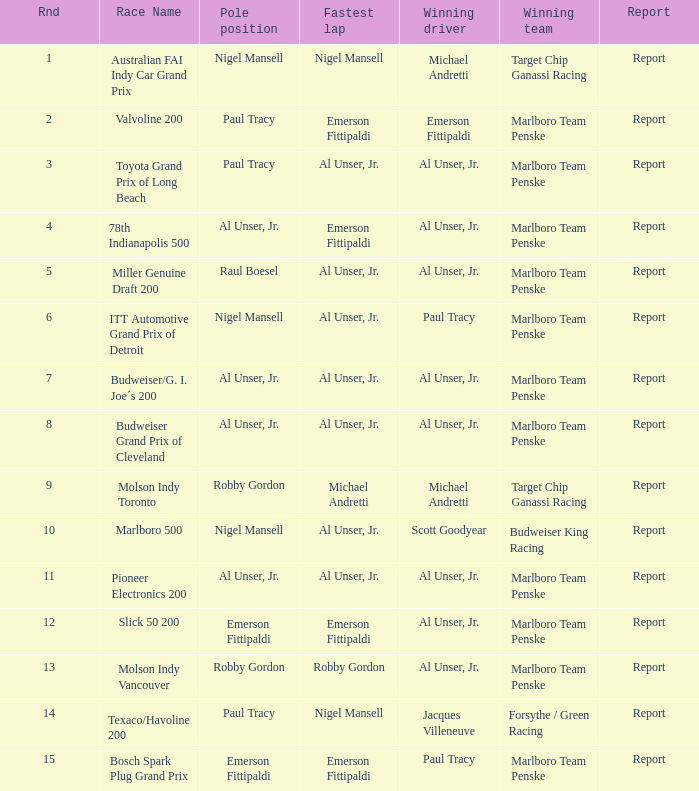What is the summary of the race in which michael andretti was victorious, and nigel mansell achieved the quickest lap? Report. 